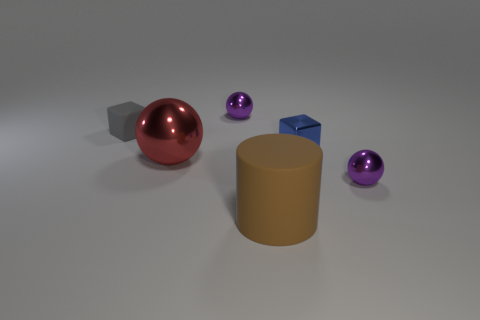There is a metal ball that is in front of the red shiny ball; is it the same color as the large cylinder?
Offer a terse response. No. The metal thing that is on the left side of the big brown object and in front of the small blue metal block is what color?
Give a very brief answer. Red. What is the shape of the rubber object that is the same size as the red metal object?
Give a very brief answer. Cylinder. Are there any tiny purple shiny things of the same shape as the red metallic object?
Your answer should be very brief. Yes. There is a purple metallic ball that is on the left side of the cylinder; is its size the same as the blue metal object?
Provide a short and direct response. Yes. What size is the metallic thing that is in front of the tiny blue cube and left of the large brown cylinder?
Ensure brevity in your answer.  Large. What number of other things are the same material as the red ball?
Your answer should be very brief. 3. There is a purple object that is left of the large brown matte cylinder; how big is it?
Your response must be concise. Small. Is the big matte object the same color as the big metallic thing?
Your answer should be compact. No. What number of tiny things are either purple metallic things or blue blocks?
Provide a succinct answer. 3. 